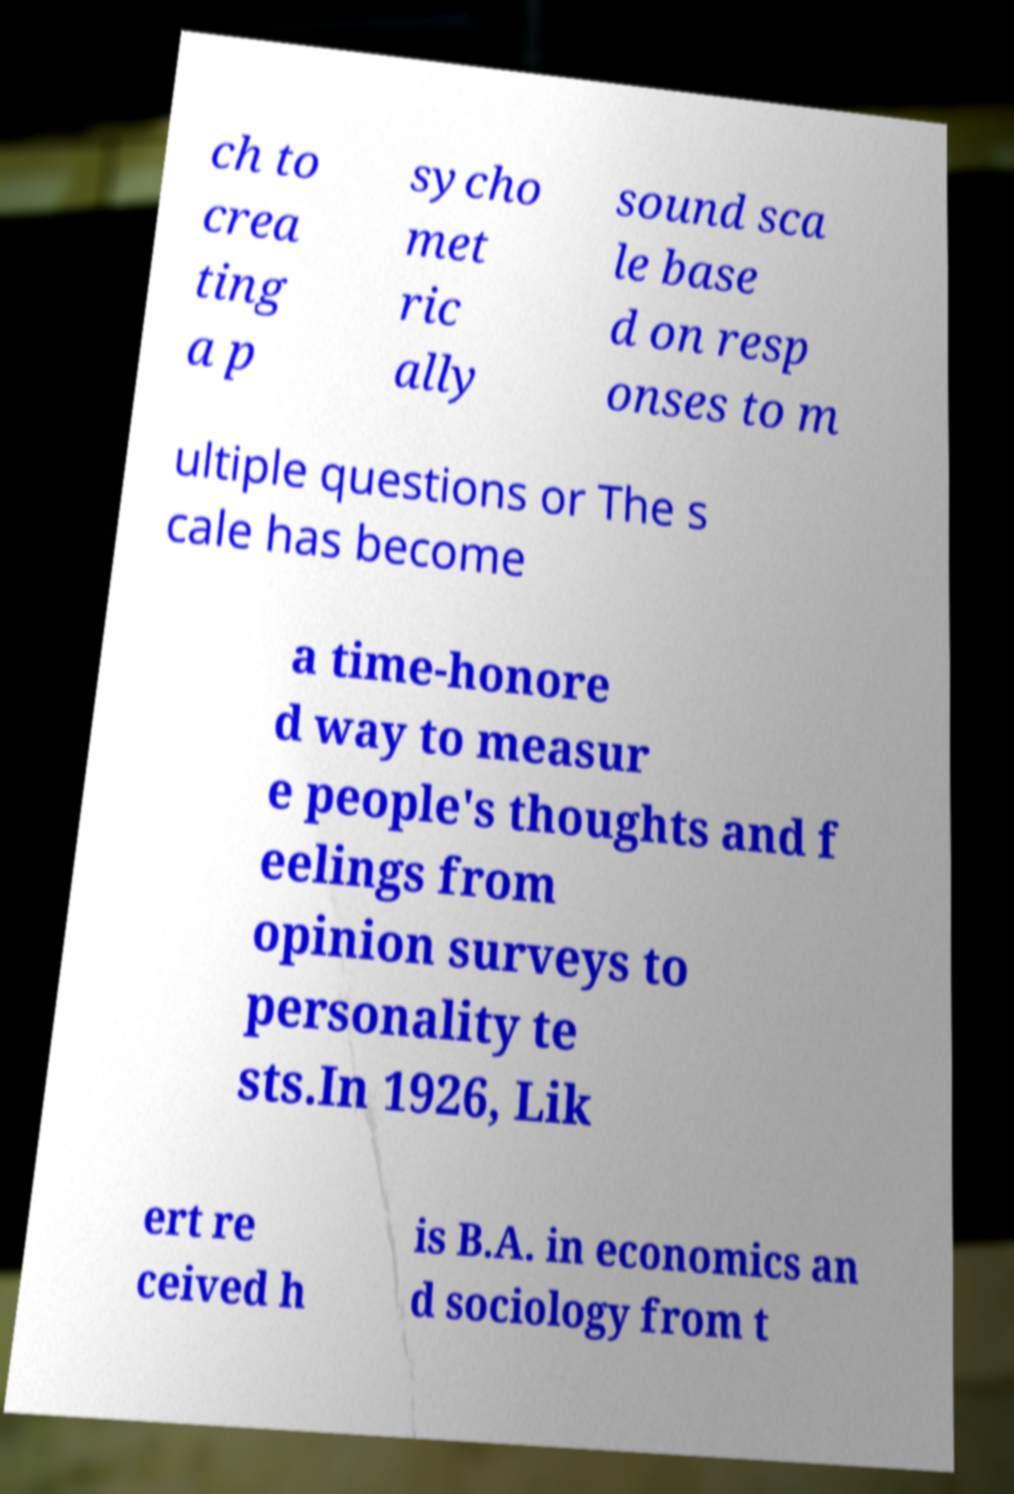For documentation purposes, I need the text within this image transcribed. Could you provide that? ch to crea ting a p sycho met ric ally sound sca le base d on resp onses to m ultiple questions or The s cale has become a time-honore d way to measur e people's thoughts and f eelings from opinion surveys to personality te sts.In 1926, Lik ert re ceived h is B.A. in economics an d sociology from t 